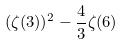Convert formula to latex. <formula><loc_0><loc_0><loc_500><loc_500>( \zeta ( 3 ) ) ^ { 2 } - \frac { 4 } { 3 } \zeta ( 6 )</formula> 